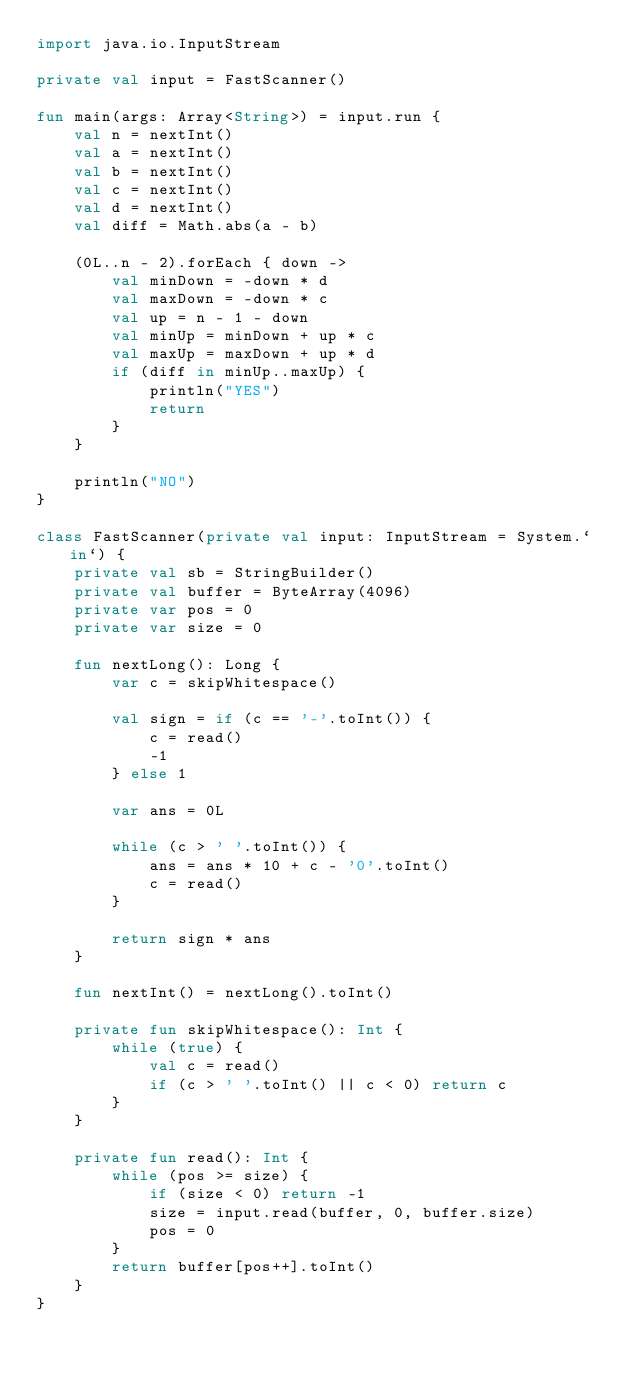Convert code to text. <code><loc_0><loc_0><loc_500><loc_500><_Kotlin_>import java.io.InputStream

private val input = FastScanner()

fun main(args: Array<String>) = input.run {
    val n = nextInt()
    val a = nextInt()
    val b = nextInt()
    val c = nextInt()
    val d = nextInt()
    val diff = Math.abs(a - b)

    (0L..n - 2).forEach { down ->
        val minDown = -down * d
        val maxDown = -down * c
        val up = n - 1 - down
        val minUp = minDown + up * c
        val maxUp = maxDown + up * d
        if (diff in minUp..maxUp) {
            println("YES")
            return
        }
    }

    println("NO")
}

class FastScanner(private val input: InputStream = System.`in`) {
    private val sb = StringBuilder()
    private val buffer = ByteArray(4096)
    private var pos = 0
    private var size = 0

    fun nextLong(): Long {
        var c = skipWhitespace()

        val sign = if (c == '-'.toInt()) {
            c = read()
            -1
        } else 1

        var ans = 0L

        while (c > ' '.toInt()) {
            ans = ans * 10 + c - '0'.toInt()
            c = read()
        }

        return sign * ans
    }

    fun nextInt() = nextLong().toInt()

    private fun skipWhitespace(): Int {
        while (true) {
            val c = read()
            if (c > ' '.toInt() || c < 0) return c
        }
    }

    private fun read(): Int {
        while (pos >= size) {
            if (size < 0) return -1
            size = input.read(buffer, 0, buffer.size)
            pos = 0
        }
        return buffer[pos++].toInt()
    }
}</code> 